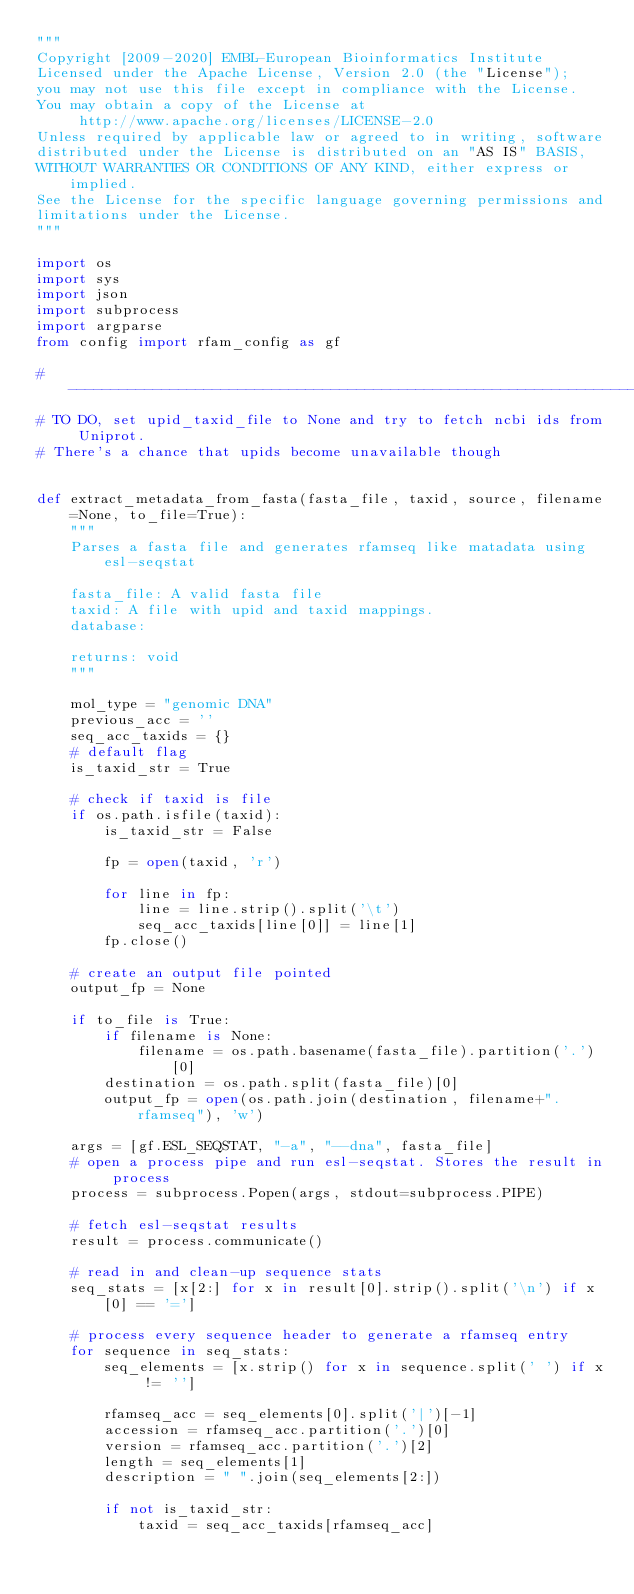Convert code to text. <code><loc_0><loc_0><loc_500><loc_500><_Python_>"""
Copyright [2009-2020] EMBL-European Bioinformatics Institute
Licensed under the Apache License, Version 2.0 (the "License");
you may not use this file except in compliance with the License.
You may obtain a copy of the License at
     http://www.apache.org/licenses/LICENSE-2.0
Unless required by applicable law or agreed to in writing, software
distributed under the License is distributed on an "AS IS" BASIS,
WITHOUT WARRANTIES OR CONDITIONS OF ANY KIND, either express or implied.
See the License for the specific language governing permissions and
limitations under the License.
"""

import os
import sys
import json
import subprocess
import argparse
from config import rfam_config as gf

# -----------------------------------------------------------------------------
# TO DO, set upid_taxid_file to None and try to fetch ncbi ids from Uniprot.
# There's a chance that upids become unavailable though


def extract_metadata_from_fasta(fasta_file, taxid, source, filename=None, to_file=True):
    """
    Parses a fasta file and generates rfamseq like matadata using esl-seqstat

    fasta_file: A valid fasta file
    taxid: A file with upid and taxid mappings.
    database:

    returns: void
    """

    mol_type = "genomic DNA"
    previous_acc = ''
    seq_acc_taxids = {}
    # default flag
    is_taxid_str = True

    # check if taxid is file 
    if os.path.isfile(taxid):
        is_taxid_str = False

        fp = open(taxid, 'r')
        
        for line in fp:
            line = line.strip().split('\t')
            seq_acc_taxids[line[0]] = line[1]
        fp.close()  

    # create an output file pointed
    output_fp = None

    if to_file is True:
        if filename is None:
            filename = os.path.basename(fasta_file).partition('.')[0]
        destination = os.path.split(fasta_file)[0]
        output_fp = open(os.path.join(destination, filename+".rfamseq"), 'w')

    args = [gf.ESL_SEQSTAT, "-a", "--dna", fasta_file]
    # open a process pipe and run esl-seqstat. Stores the result in process
    process = subprocess.Popen(args, stdout=subprocess.PIPE)
    
    # fetch esl-seqstat results
    result = process.communicate()

    # read in and clean-up sequence stats
    seq_stats = [x[2:] for x in result[0].strip().split('\n') if x[0] == '=']

    # process every sequence header to generate a rfamseq entry
    for sequence in seq_stats:
        seq_elements = [x.strip() for x in sequence.split(' ') if x != '']

        rfamseq_acc = seq_elements[0].split('|')[-1]
        accession = rfamseq_acc.partition('.')[0]
        version = rfamseq_acc.partition('.')[2]
        length = seq_elements[1]
        description = " ".join(seq_elements[2:])

        if not is_taxid_str:
            taxid = seq_acc_taxids[rfamseq_acc]
</code> 